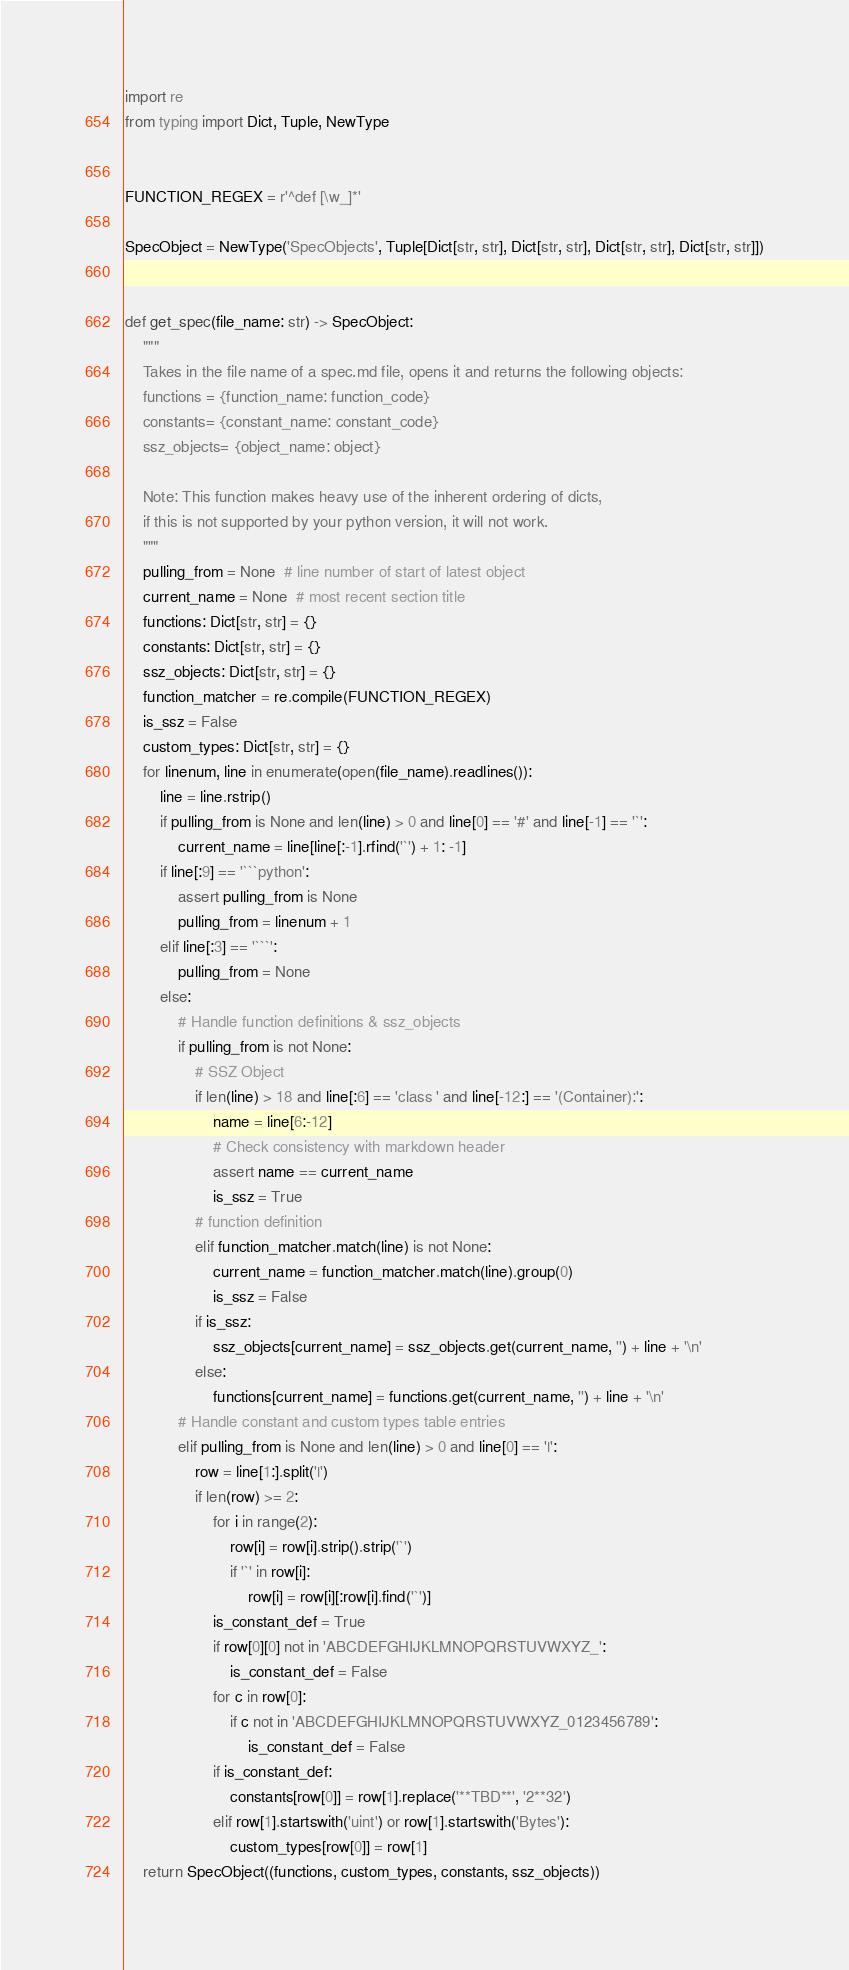Convert code to text. <code><loc_0><loc_0><loc_500><loc_500><_Python_>import re
from typing import Dict, Tuple, NewType


FUNCTION_REGEX = r'^def [\w_]*'

SpecObject = NewType('SpecObjects', Tuple[Dict[str, str], Dict[str, str], Dict[str, str], Dict[str, str]])


def get_spec(file_name: str) -> SpecObject:
    """
    Takes in the file name of a spec.md file, opens it and returns the following objects:
    functions = {function_name: function_code}
    constants= {constant_name: constant_code}
    ssz_objects= {object_name: object}

    Note: This function makes heavy use of the inherent ordering of dicts,
    if this is not supported by your python version, it will not work.
    """
    pulling_from = None  # line number of start of latest object
    current_name = None  # most recent section title
    functions: Dict[str, str] = {}
    constants: Dict[str, str] = {}
    ssz_objects: Dict[str, str] = {}
    function_matcher = re.compile(FUNCTION_REGEX)
    is_ssz = False
    custom_types: Dict[str, str] = {}
    for linenum, line in enumerate(open(file_name).readlines()):
        line = line.rstrip()
        if pulling_from is None and len(line) > 0 and line[0] == '#' and line[-1] == '`':
            current_name = line[line[:-1].rfind('`') + 1: -1]
        if line[:9] == '```python':
            assert pulling_from is None
            pulling_from = linenum + 1
        elif line[:3] == '```':
            pulling_from = None
        else:
            # Handle function definitions & ssz_objects
            if pulling_from is not None:
                # SSZ Object
                if len(line) > 18 and line[:6] == 'class ' and line[-12:] == '(Container):':
                    name = line[6:-12]
                    # Check consistency with markdown header
                    assert name == current_name
                    is_ssz = True
                # function definition
                elif function_matcher.match(line) is not None:
                    current_name = function_matcher.match(line).group(0)
                    is_ssz = False
                if is_ssz:
                    ssz_objects[current_name] = ssz_objects.get(current_name, '') + line + '\n'
                else:
                    functions[current_name] = functions.get(current_name, '') + line + '\n'
            # Handle constant and custom types table entries
            elif pulling_from is None and len(line) > 0 and line[0] == '|':
                row = line[1:].split('|')
                if len(row) >= 2:
                    for i in range(2):
                        row[i] = row[i].strip().strip('`')
                        if '`' in row[i]:
                            row[i] = row[i][:row[i].find('`')]
                    is_constant_def = True
                    if row[0][0] not in 'ABCDEFGHIJKLMNOPQRSTUVWXYZ_':
                        is_constant_def = False
                    for c in row[0]:
                        if c not in 'ABCDEFGHIJKLMNOPQRSTUVWXYZ_0123456789':
                            is_constant_def = False
                    if is_constant_def:
                        constants[row[0]] = row[1].replace('**TBD**', '2**32')
                    elif row[1].startswith('uint') or row[1].startswith('Bytes'):
                        custom_types[row[0]] = row[1]
    return SpecObject((functions, custom_types, constants, ssz_objects))
</code> 